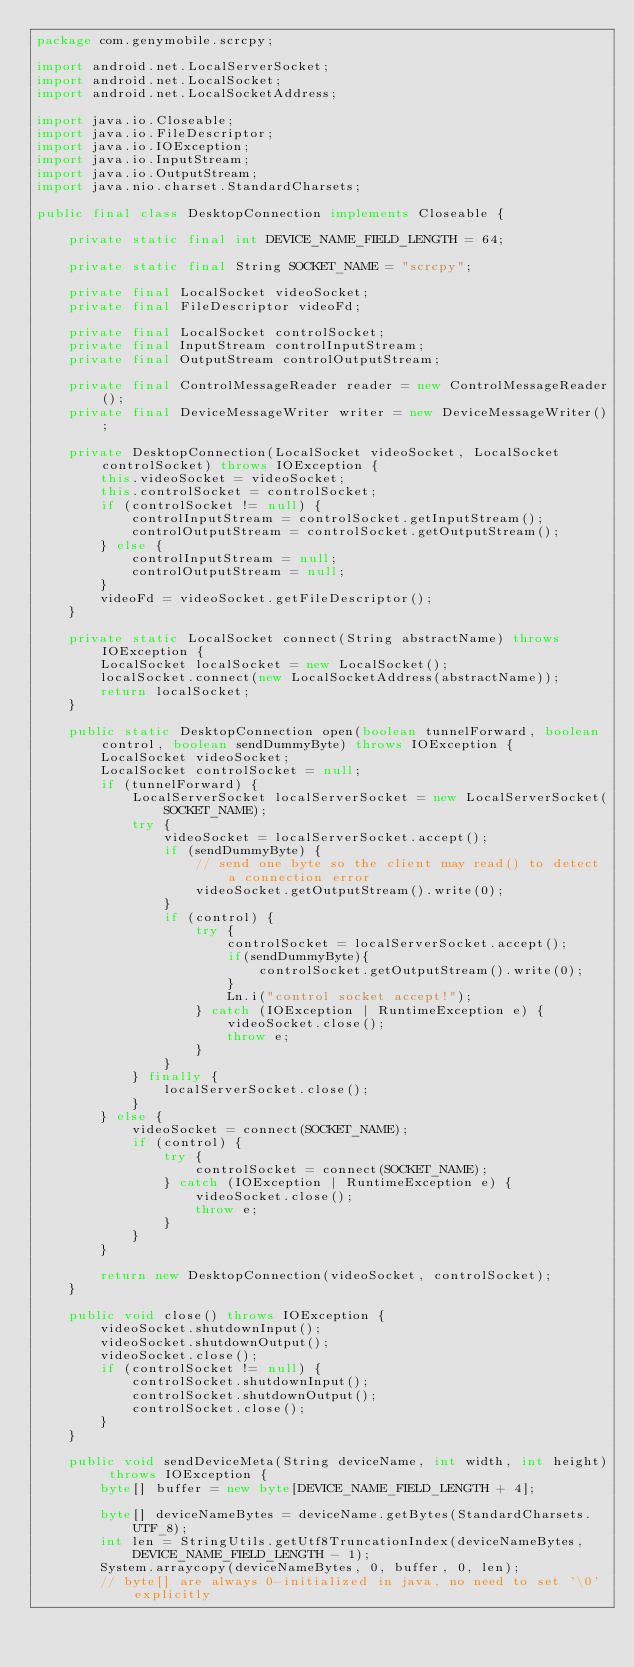<code> <loc_0><loc_0><loc_500><loc_500><_Java_>package com.genymobile.scrcpy;

import android.net.LocalServerSocket;
import android.net.LocalSocket;
import android.net.LocalSocketAddress;

import java.io.Closeable;
import java.io.FileDescriptor;
import java.io.IOException;
import java.io.InputStream;
import java.io.OutputStream;
import java.nio.charset.StandardCharsets;

public final class DesktopConnection implements Closeable {

    private static final int DEVICE_NAME_FIELD_LENGTH = 64;

    private static final String SOCKET_NAME = "scrcpy";

    private final LocalSocket videoSocket;
    private final FileDescriptor videoFd;

    private final LocalSocket controlSocket;
    private final InputStream controlInputStream;
    private final OutputStream controlOutputStream;

    private final ControlMessageReader reader = new ControlMessageReader();
    private final DeviceMessageWriter writer = new DeviceMessageWriter();

    private DesktopConnection(LocalSocket videoSocket, LocalSocket controlSocket) throws IOException {
        this.videoSocket = videoSocket;
        this.controlSocket = controlSocket;
        if (controlSocket != null) {
            controlInputStream = controlSocket.getInputStream();
            controlOutputStream = controlSocket.getOutputStream();
        } else {
            controlInputStream = null;
            controlOutputStream = null;
        }
        videoFd = videoSocket.getFileDescriptor();
    }

    private static LocalSocket connect(String abstractName) throws IOException {
        LocalSocket localSocket = new LocalSocket();
        localSocket.connect(new LocalSocketAddress(abstractName));
        return localSocket;
    }

    public static DesktopConnection open(boolean tunnelForward, boolean control, boolean sendDummyByte) throws IOException {
        LocalSocket videoSocket;
        LocalSocket controlSocket = null;
        if (tunnelForward) {
            LocalServerSocket localServerSocket = new LocalServerSocket(SOCKET_NAME);
            try {
                videoSocket = localServerSocket.accept();
                if (sendDummyByte) {
                    // send one byte so the client may read() to detect a connection error
                    videoSocket.getOutputStream().write(0);
                }
                if (control) {
                    try {
                        controlSocket = localServerSocket.accept();
                        if(sendDummyByte){
                            controlSocket.getOutputStream().write(0);
                        }
                        Ln.i("control socket accept!");
                    } catch (IOException | RuntimeException e) {
                        videoSocket.close();
                        throw e;
                    }
                }
            } finally {
                localServerSocket.close();
            }
        } else {
            videoSocket = connect(SOCKET_NAME);
            if (control) {
                try {
                    controlSocket = connect(SOCKET_NAME);
                } catch (IOException | RuntimeException e) {
                    videoSocket.close();
                    throw e;
                }
            }
        }

        return new DesktopConnection(videoSocket, controlSocket);
    }

    public void close() throws IOException {
        videoSocket.shutdownInput();
        videoSocket.shutdownOutput();
        videoSocket.close();
        if (controlSocket != null) {
            controlSocket.shutdownInput();
            controlSocket.shutdownOutput();
            controlSocket.close();
        }
    }

    public void sendDeviceMeta(String deviceName, int width, int height) throws IOException {
        byte[] buffer = new byte[DEVICE_NAME_FIELD_LENGTH + 4];

        byte[] deviceNameBytes = deviceName.getBytes(StandardCharsets.UTF_8);
        int len = StringUtils.getUtf8TruncationIndex(deviceNameBytes, DEVICE_NAME_FIELD_LENGTH - 1);
        System.arraycopy(deviceNameBytes, 0, buffer, 0, len);
        // byte[] are always 0-initialized in java, no need to set '\0' explicitly
</code> 